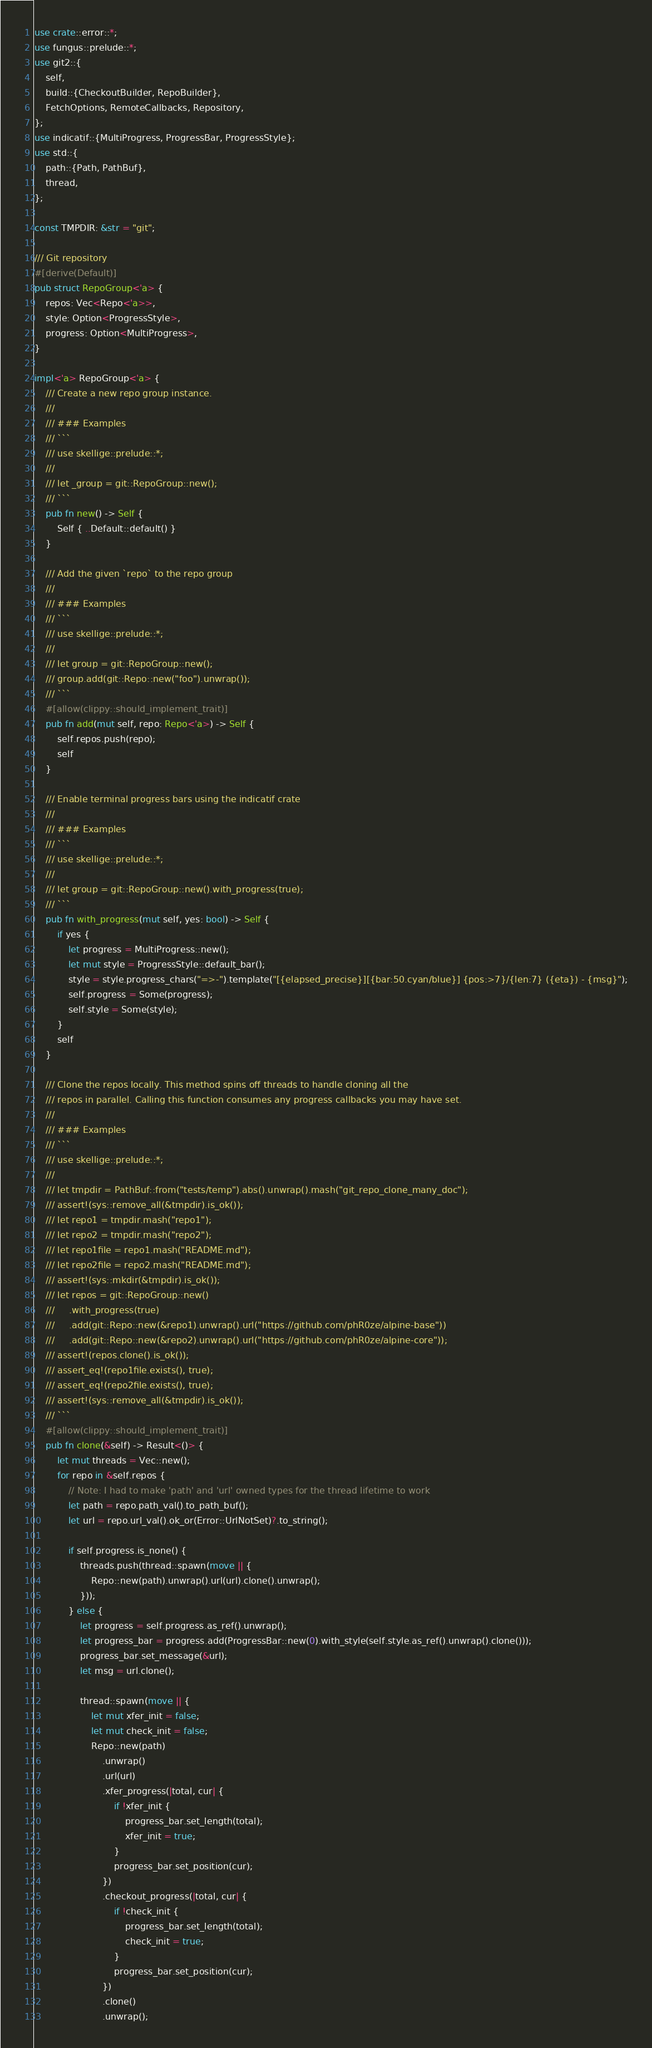Convert code to text. <code><loc_0><loc_0><loc_500><loc_500><_Rust_>use crate::error::*;
use fungus::prelude::*;
use git2::{
    self,
    build::{CheckoutBuilder, RepoBuilder},
    FetchOptions, RemoteCallbacks, Repository,
};
use indicatif::{MultiProgress, ProgressBar, ProgressStyle};
use std::{
    path::{Path, PathBuf},
    thread,
};

const TMPDIR: &str = "git";

/// Git repository
#[derive(Default)]
pub struct RepoGroup<'a> {
    repos: Vec<Repo<'a>>,
    style: Option<ProgressStyle>,
    progress: Option<MultiProgress>,
}

impl<'a> RepoGroup<'a> {
    /// Create a new repo group instance.
    ///
    /// ### Examples
    /// ```
    /// use skellige::prelude::*;
    ///
    /// let _group = git::RepoGroup::new();
    /// ```
    pub fn new() -> Self {
        Self { ..Default::default() }
    }

    /// Add the given `repo` to the repo group
    ///
    /// ### Examples
    /// ```
    /// use skellige::prelude::*;
    ///
    /// let group = git::RepoGroup::new();
    /// group.add(git::Repo::new("foo").unwrap());
    /// ```
    #[allow(clippy::should_implement_trait)]
    pub fn add(mut self, repo: Repo<'a>) -> Self {
        self.repos.push(repo);
        self
    }

    /// Enable terminal progress bars using the indicatif crate
    ///
    /// ### Examples
    /// ```
    /// use skellige::prelude::*;
    ///
    /// let group = git::RepoGroup::new().with_progress(true);
    /// ```
    pub fn with_progress(mut self, yes: bool) -> Self {
        if yes {
            let progress = MultiProgress::new();
            let mut style = ProgressStyle::default_bar();
            style = style.progress_chars("=>-").template("[{elapsed_precise}][{bar:50.cyan/blue}] {pos:>7}/{len:7} ({eta}) - {msg}");
            self.progress = Some(progress);
            self.style = Some(style);
        }
        self
    }

    /// Clone the repos locally. This method spins off threads to handle cloning all the
    /// repos in parallel. Calling this function consumes any progress callbacks you may have set.
    ///
    /// ### Examples
    /// ```
    /// use skellige::prelude::*;
    ///
    /// let tmpdir = PathBuf::from("tests/temp").abs().unwrap().mash("git_repo_clone_many_doc");
    /// assert!(sys::remove_all(&tmpdir).is_ok());
    /// let repo1 = tmpdir.mash("repo1");
    /// let repo2 = tmpdir.mash("repo2");
    /// let repo1file = repo1.mash("README.md");
    /// let repo2file = repo2.mash("README.md");
    /// assert!(sys::mkdir(&tmpdir).is_ok());
    /// let repos = git::RepoGroup::new()
    ///     .with_progress(true)
    ///     .add(git::Repo::new(&repo1).unwrap().url("https://github.com/phR0ze/alpine-base"))
    ///     .add(git::Repo::new(&repo2).unwrap().url("https://github.com/phR0ze/alpine-core"));
    /// assert!(repos.clone().is_ok());
    /// assert_eq!(repo1file.exists(), true);
    /// assert_eq!(repo2file.exists(), true);
    /// assert!(sys::remove_all(&tmpdir).is_ok());
    /// ```
    #[allow(clippy::should_implement_trait)]
    pub fn clone(&self) -> Result<()> {
        let mut threads = Vec::new();
        for repo in &self.repos {
            // Note: I had to make 'path' and 'url' owned types for the thread lifetime to work
            let path = repo.path_val().to_path_buf();
            let url = repo.url_val().ok_or(Error::UrlNotSet)?.to_string();

            if self.progress.is_none() {
                threads.push(thread::spawn(move || {
                    Repo::new(path).unwrap().url(url).clone().unwrap();
                }));
            } else {
                let progress = self.progress.as_ref().unwrap();
                let progress_bar = progress.add(ProgressBar::new(0).with_style(self.style.as_ref().unwrap().clone()));
                progress_bar.set_message(&url);
                let msg = url.clone();

                thread::spawn(move || {
                    let mut xfer_init = false;
                    let mut check_init = false;
                    Repo::new(path)
                        .unwrap()
                        .url(url)
                        .xfer_progress(|total, cur| {
                            if !xfer_init {
                                progress_bar.set_length(total);
                                xfer_init = true;
                            }
                            progress_bar.set_position(cur);
                        })
                        .checkout_progress(|total, cur| {
                            if !check_init {
                                progress_bar.set_length(total);
                                check_init = true;
                            }
                            progress_bar.set_position(cur);
                        })
                        .clone()
                        .unwrap();
</code> 